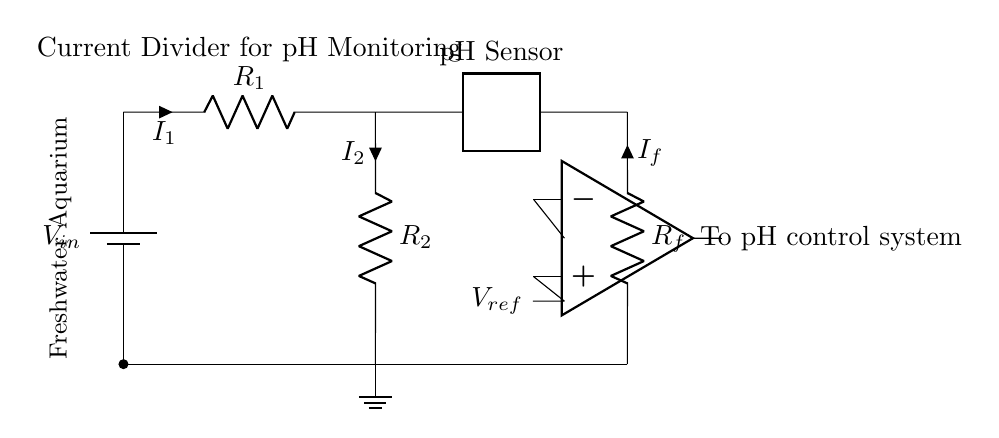What is the input voltage in the circuit? The input voltage is labeled as V in, which is indicated directly next to the battery symbol in the circuit diagram.
Answer: V in What are the values of the resistors in the current divider? The resistors are labeled as R one and R two, representing their individual resistance values. However, the specific values are not provided in the diagram.
Answer: R one, R two Which component senses the pH level? The pH sensor is shown as a two-port element connected in the circuit, providing pH level readings.
Answer: pH sensor What is the role of the op-amp in this circuit? The op-amp serves for signal conditioning, meaning it processes the pH sensor output to ensure accurate readings before transmitting it to the pH control system.
Answer: Signal conditioning How is the current divided in this circuit? The current is divided by the resistors R one and R two, following the current divider rule, which states that the current through each resistor is inversely proportional to its resistance.
Answer: By resistors What is the connection between the pH sensor and the feedback loop? The pH sensor is directly connected to the feedback loop, influencing the feedback resistor designated as R f, which helps maintain desired pH levels based on the sensor readings.
Answer: Directly connected What is the purpose of the feedback resistor in this circuit? The feedback resistor R f is used to adjust and stabilize the output of the pH monitoring system, ensuring that the pH levels in the aquarium are maintained optimally.
Answer: Adjust and stabilize 